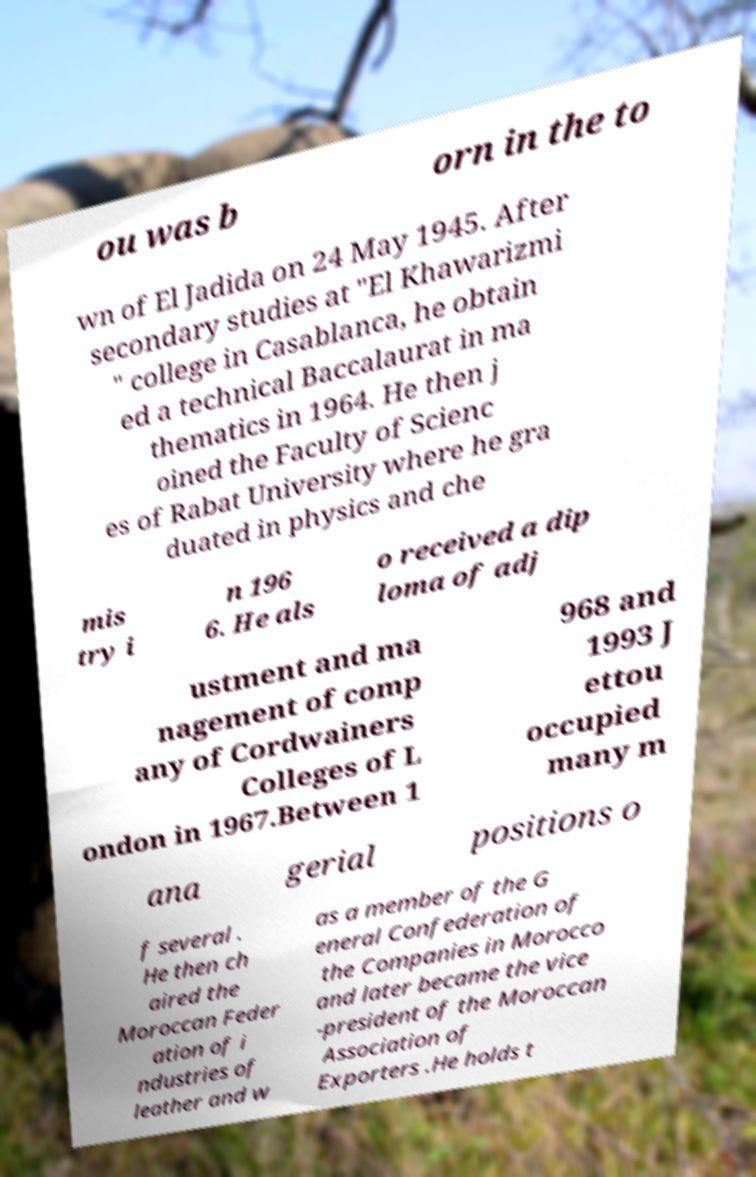There's text embedded in this image that I need extracted. Can you transcribe it verbatim? ou was b orn in the to wn of El Jadida on 24 May 1945. After secondary studies at "El Khawarizmi " college in Casablanca, he obtain ed a technical Baccalaurat in ma thematics in 1964. He then j oined the Faculty of Scienc es of Rabat University where he gra duated in physics and che mis try i n 196 6. He als o received a dip loma of adj ustment and ma nagement of comp any of Cordwainers Colleges of L ondon in 1967.Between 1 968 and 1993 J ettou occupied many m ana gerial positions o f several . He then ch aired the Moroccan Feder ation of i ndustries of leather and w as a member of the G eneral Confederation of the Companies in Morocco and later became the vice -president of the Moroccan Association of Exporters .He holds t 